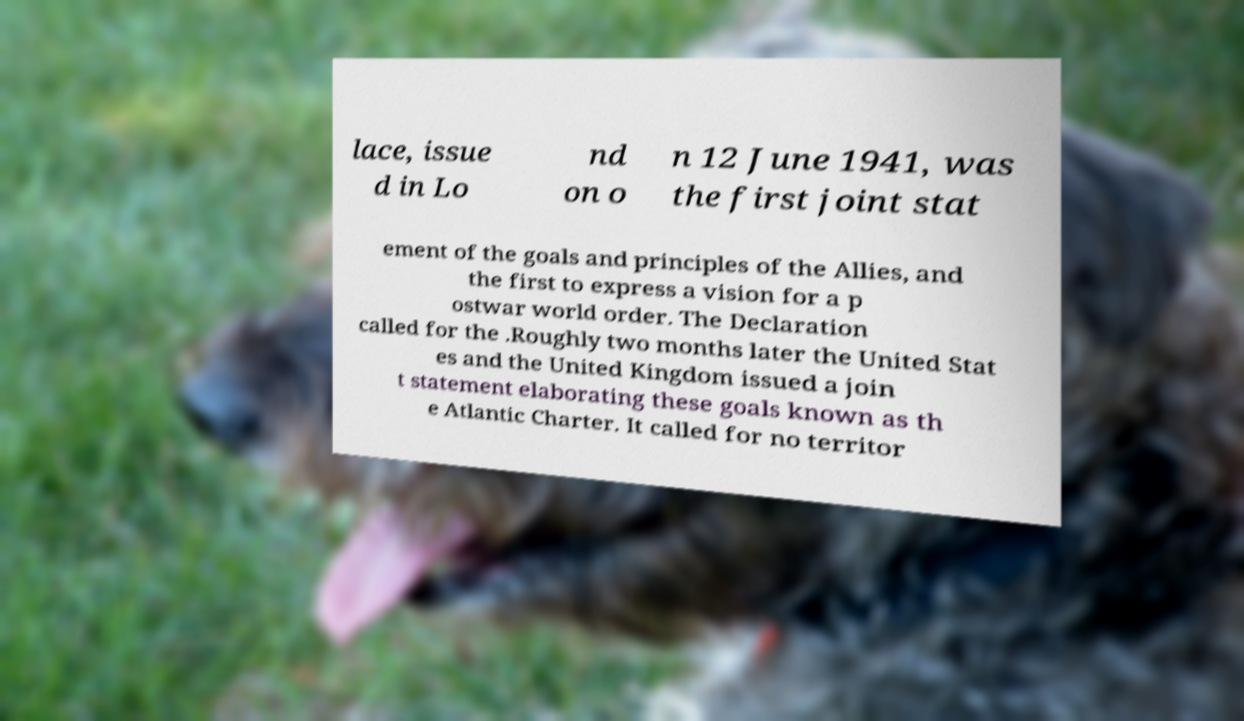Could you assist in decoding the text presented in this image and type it out clearly? lace, issue d in Lo nd on o n 12 June 1941, was the first joint stat ement of the goals and principles of the Allies, and the first to express a vision for a p ostwar world order. The Declaration called for the .Roughly two months later the United Stat es and the United Kingdom issued a join t statement elaborating these goals known as th e Atlantic Charter. It called for no territor 